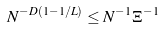Convert formula to latex. <formula><loc_0><loc_0><loc_500><loc_500>N ^ { - D ( 1 - 1 / L ) } & \leq N ^ { - 1 } \Xi ^ { - 1 }</formula> 